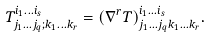Convert formula to latex. <formula><loc_0><loc_0><loc_500><loc_500>T ^ { i _ { 1 } \dots i _ { s } } _ { j _ { 1 } \dots j _ { q } ; k _ { 1 } \dots k _ { r } } = ( \nabla ^ { r } T ) ^ { i _ { 1 } \dots i _ { s } } _ { j _ { 1 } \dots j _ { q } k _ { 1 } \dots k _ { r } } .</formula> 